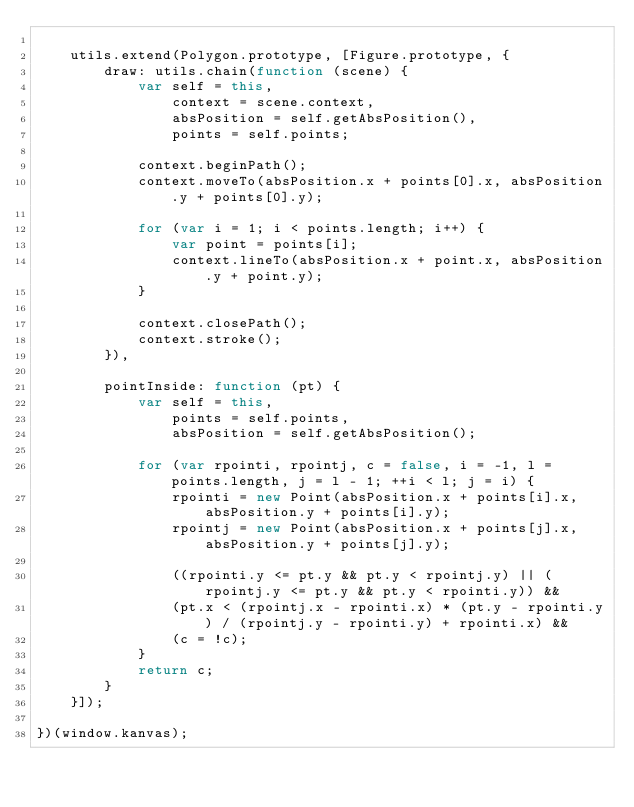<code> <loc_0><loc_0><loc_500><loc_500><_JavaScript_>
    utils.extend(Polygon.prototype, [Figure.prototype, {
        draw: utils.chain(function (scene) {
            var self = this,
                context = scene.context,
                absPosition = self.getAbsPosition(),
                points = self.points;

            context.beginPath();
            context.moveTo(absPosition.x + points[0].x, absPosition.y + points[0].y);

            for (var i = 1; i < points.length; i++) {
                var point = points[i];
                context.lineTo(absPosition.x + point.x, absPosition.y + point.y);
            }

            context.closePath();
            context.stroke();
        }),

        pointInside: function (pt) {
            var self = this,
                points = self.points,
                absPosition = self.getAbsPosition();

            for (var rpointi, rpointj, c = false, i = -1, l = points.length, j = l - 1; ++i < l; j = i) {
                rpointi = new Point(absPosition.x + points[i].x, absPosition.y + points[i].y);
                rpointj = new Point(absPosition.x + points[j].x, absPosition.y + points[j].y);

                ((rpointi.y <= pt.y && pt.y < rpointj.y) || (rpointj.y <= pt.y && pt.y < rpointi.y)) &&
                (pt.x < (rpointj.x - rpointi.x) * (pt.y - rpointi.y) / (rpointj.y - rpointi.y) + rpointi.x) &&
                (c = !c);
            }
            return c;
        }
    }]);

})(window.kanvas);
</code> 